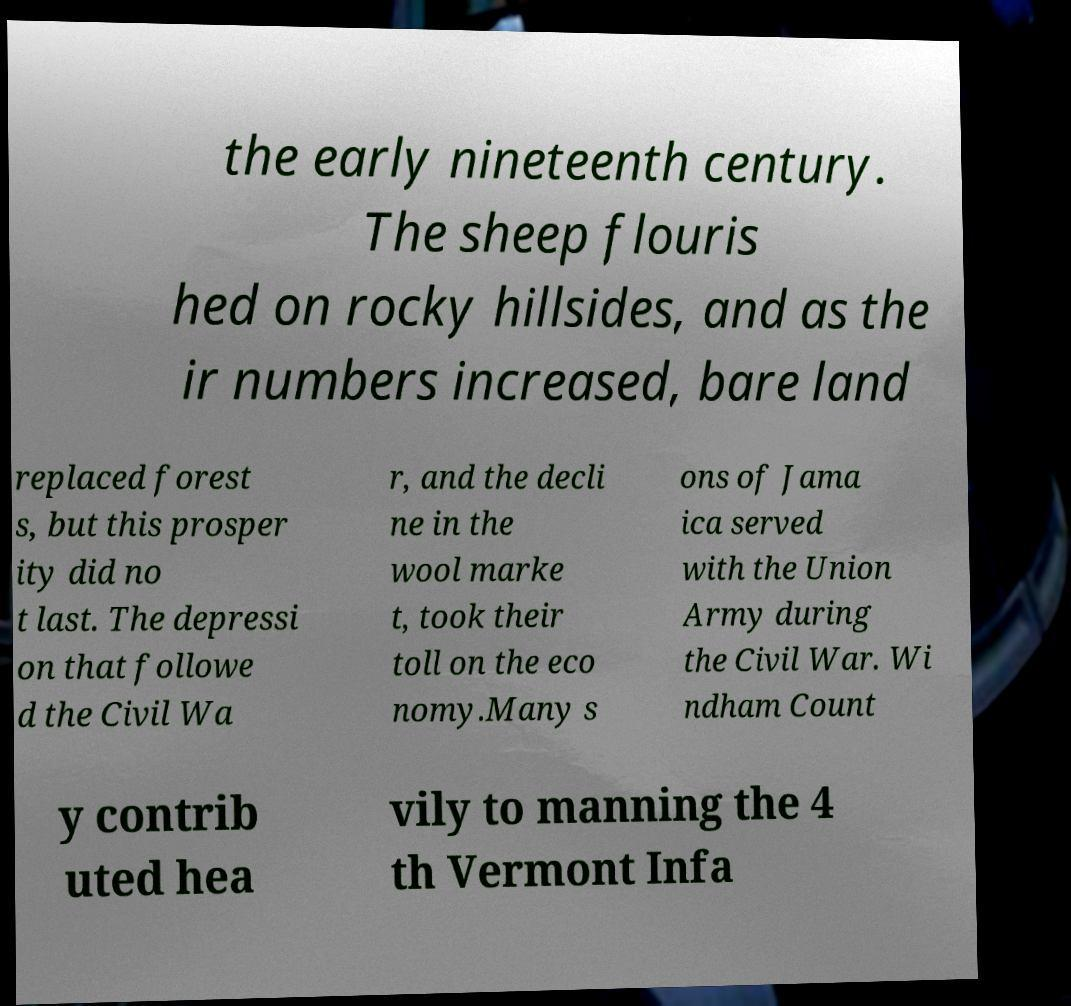Please identify and transcribe the text found in this image. the early nineteenth century. The sheep flouris hed on rocky hillsides, and as the ir numbers increased, bare land replaced forest s, but this prosper ity did no t last. The depressi on that followe d the Civil Wa r, and the decli ne in the wool marke t, took their toll on the eco nomy.Many s ons of Jama ica served with the Union Army during the Civil War. Wi ndham Count y contrib uted hea vily to manning the 4 th Vermont Infa 